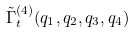<formula> <loc_0><loc_0><loc_500><loc_500>\tilde { \Gamma } _ { t } ^ { ( 4 ) } ( q _ { 1 } , q _ { 2 } , q _ { 3 } , q _ { 4 } )</formula> 